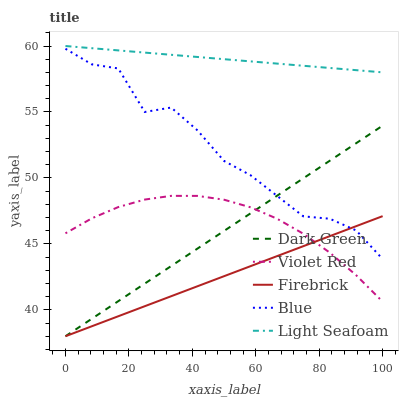Does Firebrick have the minimum area under the curve?
Answer yes or no. Yes. Does Light Seafoam have the maximum area under the curve?
Answer yes or no. Yes. Does Violet Red have the minimum area under the curve?
Answer yes or no. No. Does Violet Red have the maximum area under the curve?
Answer yes or no. No. Is Light Seafoam the smoothest?
Answer yes or no. Yes. Is Blue the roughest?
Answer yes or no. Yes. Is Violet Red the smoothest?
Answer yes or no. No. Is Violet Red the roughest?
Answer yes or no. No. Does Firebrick have the lowest value?
Answer yes or no. Yes. Does Violet Red have the lowest value?
Answer yes or no. No. Does Light Seafoam have the highest value?
Answer yes or no. Yes. Does Violet Red have the highest value?
Answer yes or no. No. Is Firebrick less than Light Seafoam?
Answer yes or no. Yes. Is Blue greater than Violet Red?
Answer yes or no. Yes. Does Blue intersect Dark Green?
Answer yes or no. Yes. Is Blue less than Dark Green?
Answer yes or no. No. Is Blue greater than Dark Green?
Answer yes or no. No. Does Firebrick intersect Light Seafoam?
Answer yes or no. No. 